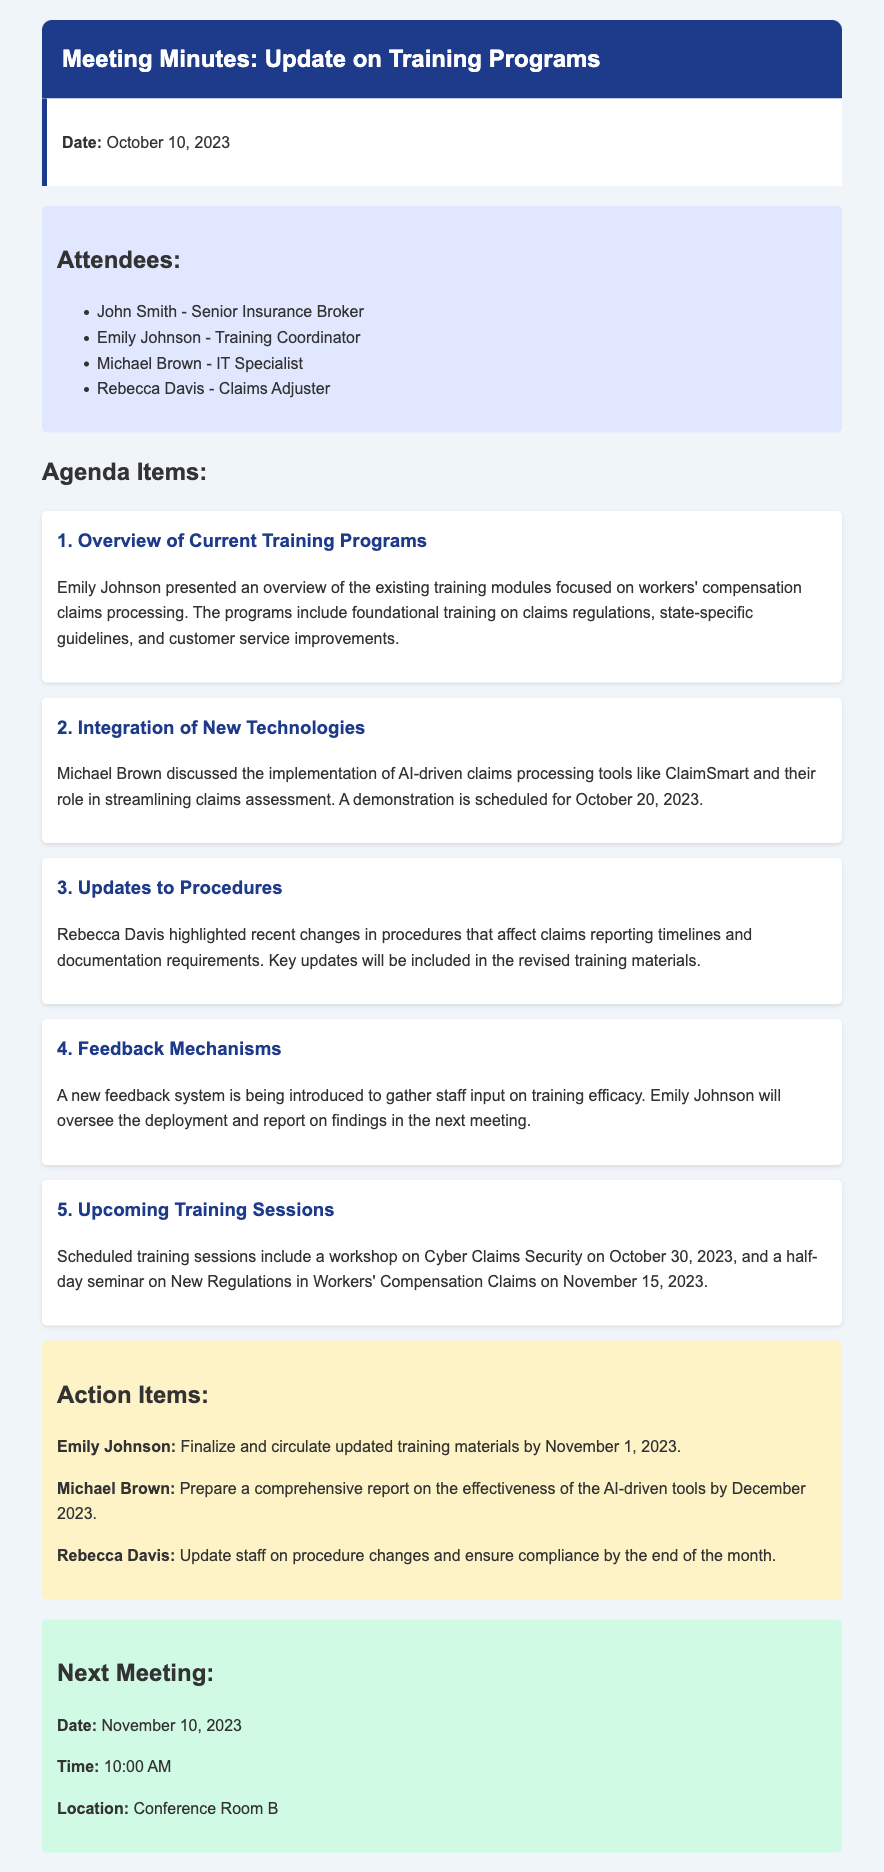What is the date of the meeting? The date of the meeting is specified at the beginning of the document.
Answer: October 10, 2023 Who presented an overview of the current training programs? The meeting minutes list the attendees and their roles; Emily Johnson presented the overview.
Answer: Emily Johnson What technology was discussed for claims processing? The document refers to a specific AI-driven tool mentioned during the meeting.
Answer: ClaimSmart When is the demonstration of the new technology scheduled? The exact date for the demonstration is mentioned in the agenda items.
Answer: October 20, 2023 What new training session is scheduled for October 30, 2023? The agenda item outlines upcoming training sessions, including one on Cyber Claims Security.
Answer: Cyber Claims Security Who is responsible for updating staff on procedure changes? The action items specify the person assigned to this task.
Answer: Rebecca Davis What is the next meeting date? The next meeting date is provided towards the end of the minutes.
Answer: November 10, 2023 How will feedback on training efficacy be gathered? The document states that a new feedback system is being introduced for this purpose.
Answer: New feedback system What is included in the upcoming training programs? The agenda outlines training sessions that will be conducted in the future.
Answer: Cyber Claims Security and New Regulations in Workers' Compensation Claims What is the deadline for circulating updated training materials? The action items include a specific completion date for this task.
Answer: November 1, 2023 